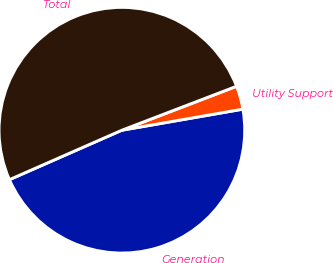Convert chart. <chart><loc_0><loc_0><loc_500><loc_500><pie_chart><fcel>Generation<fcel>Utility Support<fcel>Total<nl><fcel>46.15%<fcel>3.08%<fcel>50.77%<nl></chart> 